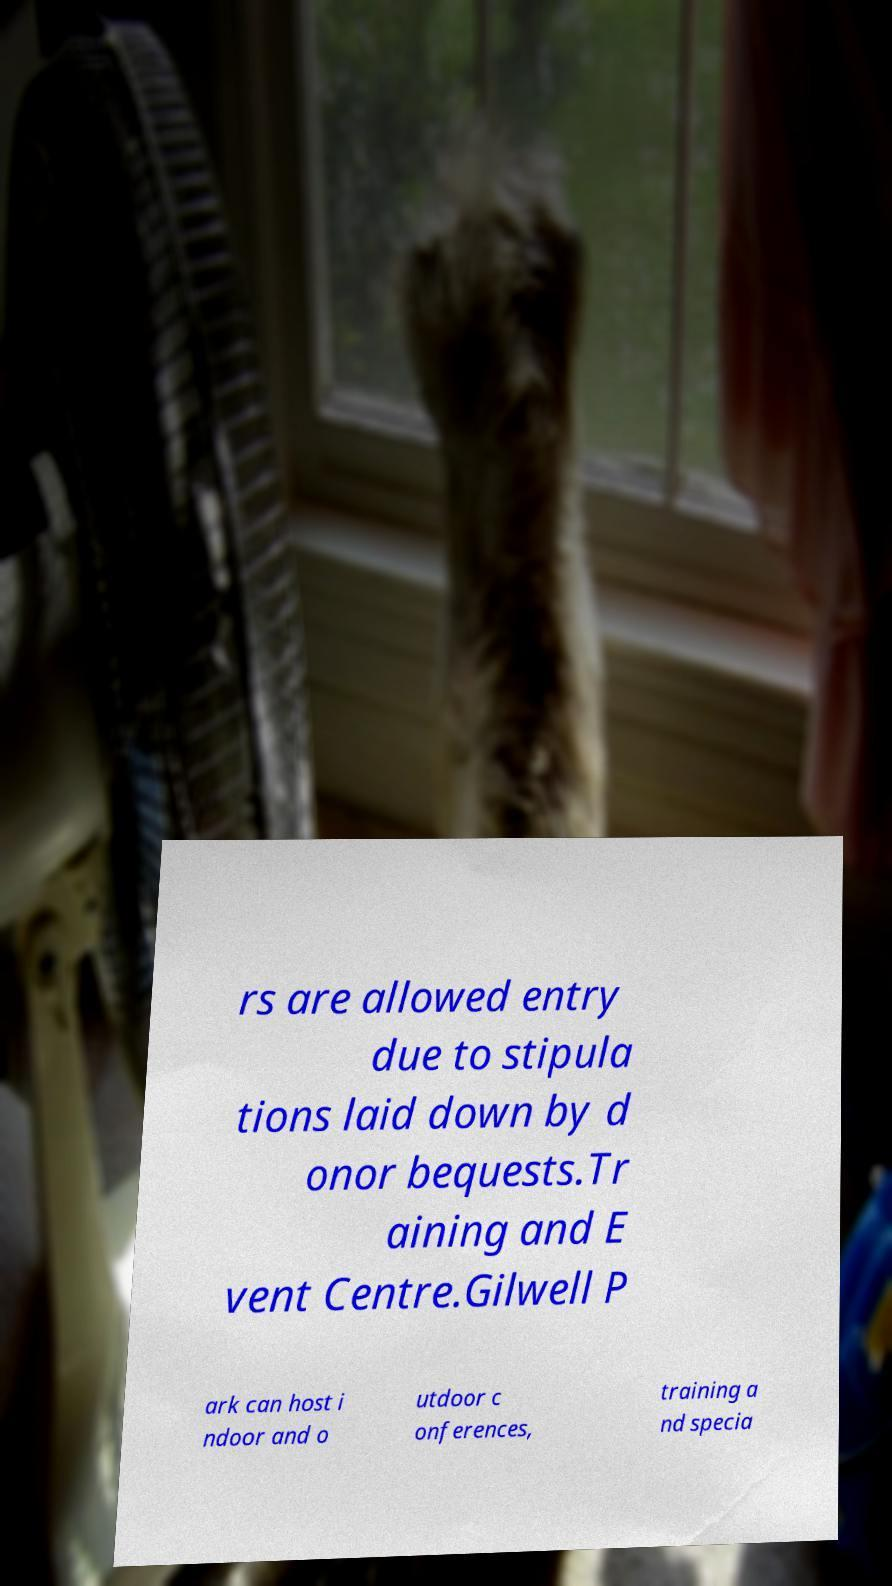Could you assist in decoding the text presented in this image and type it out clearly? rs are allowed entry due to stipula tions laid down by d onor bequests.Tr aining and E vent Centre.Gilwell P ark can host i ndoor and o utdoor c onferences, training a nd specia 